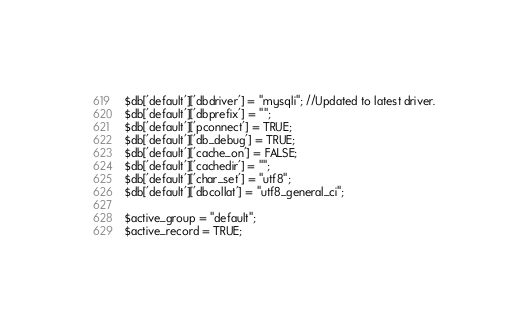Convert code to text. <code><loc_0><loc_0><loc_500><loc_500><_PHP_>$db['default']['dbdriver'] = "mysqli"; //Updated to latest driver.
$db['default']['dbprefix'] = "";
$db['default']['pconnect'] = TRUE;
$db['default']['db_debug'] = TRUE;
$db['default']['cache_on'] = FALSE;
$db['default']['cachedir'] = "";
$db['default']['char_set'] = "utf8";
$db['default']['dbcollat'] = "utf8_general_ci";

$active_group = "default";
$active_record = TRUE;
</code> 